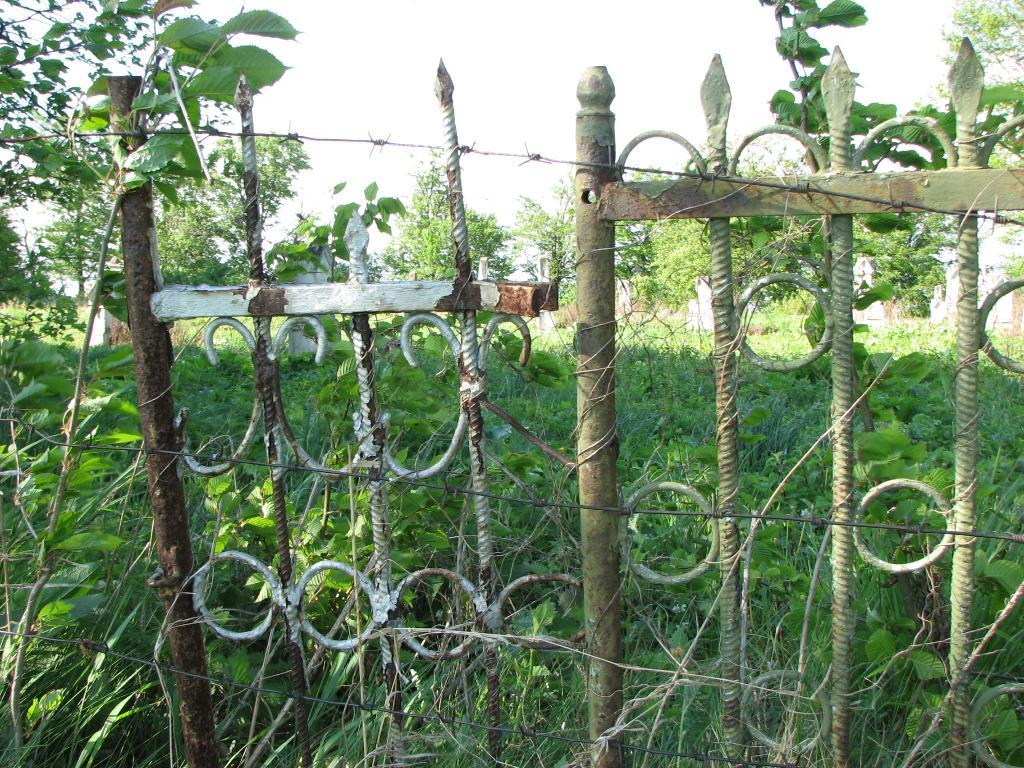What type of living organisms can be seen in the image? Plants can be seen in the image. What is located in the middle of the image? There is a fencing in the middle of the image. What is visible at the top of the image? The sky is visible at the top of the image. What shape is the spark that can be seen in the image? There is no spark present in the image. What do the plants in the image believe about the weather? Plants do not have the ability to believe anything, as they are living organisms and not sentient beings. 